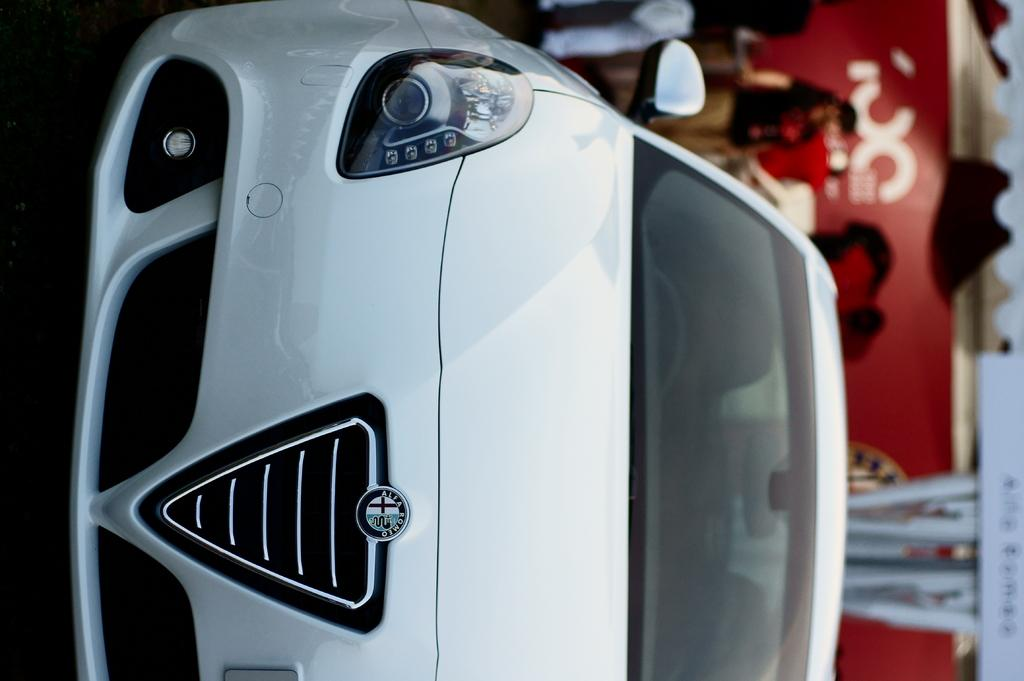What is the main subject of the image? The main subject of the image is a car. Can you describe the car in the image? The car is white. Are there any people present in the image? Yes, there are people in the image. How would you describe the background of the image? The background of the image is blurred. What type of tomatoes can be seen in the image? There are no tomatoes present in the image. Is there a market visible in the background of the image? There is no market visible in the image; the background is blurred. 